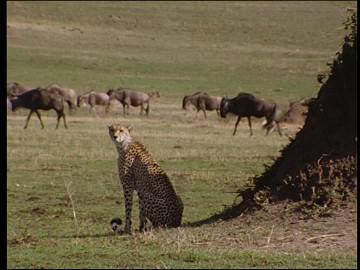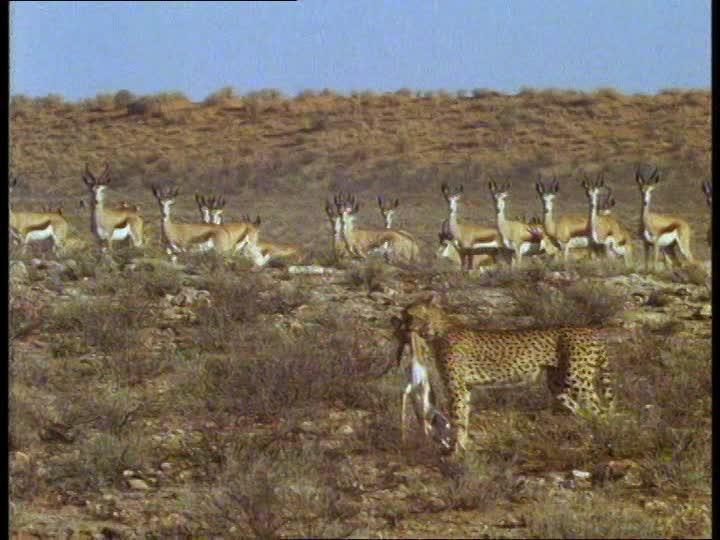The first image is the image on the left, the second image is the image on the right. Evaluate the accuracy of this statement regarding the images: "Atleast one image contains 2 cheetahs fighting another animal". Is it true? Answer yes or no. No. 